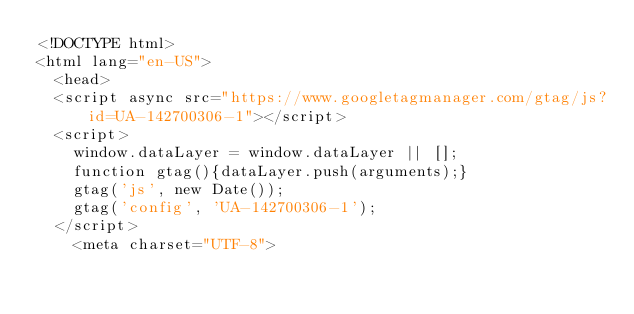<code> <loc_0><loc_0><loc_500><loc_500><_HTML_><!DOCTYPE html>
<html lang="en-US">
  <head>    
  <script async src="https://www.googletagmanager.com/gtag/js?id=UA-142700306-1"></script>
  <script>
    window.dataLayer = window.dataLayer || [];
    function gtag(){dataLayer.push(arguments);}
    gtag('js', new Date());
    gtag('config', 'UA-142700306-1');
  </script>
    <meta charset="UTF-8"></code> 